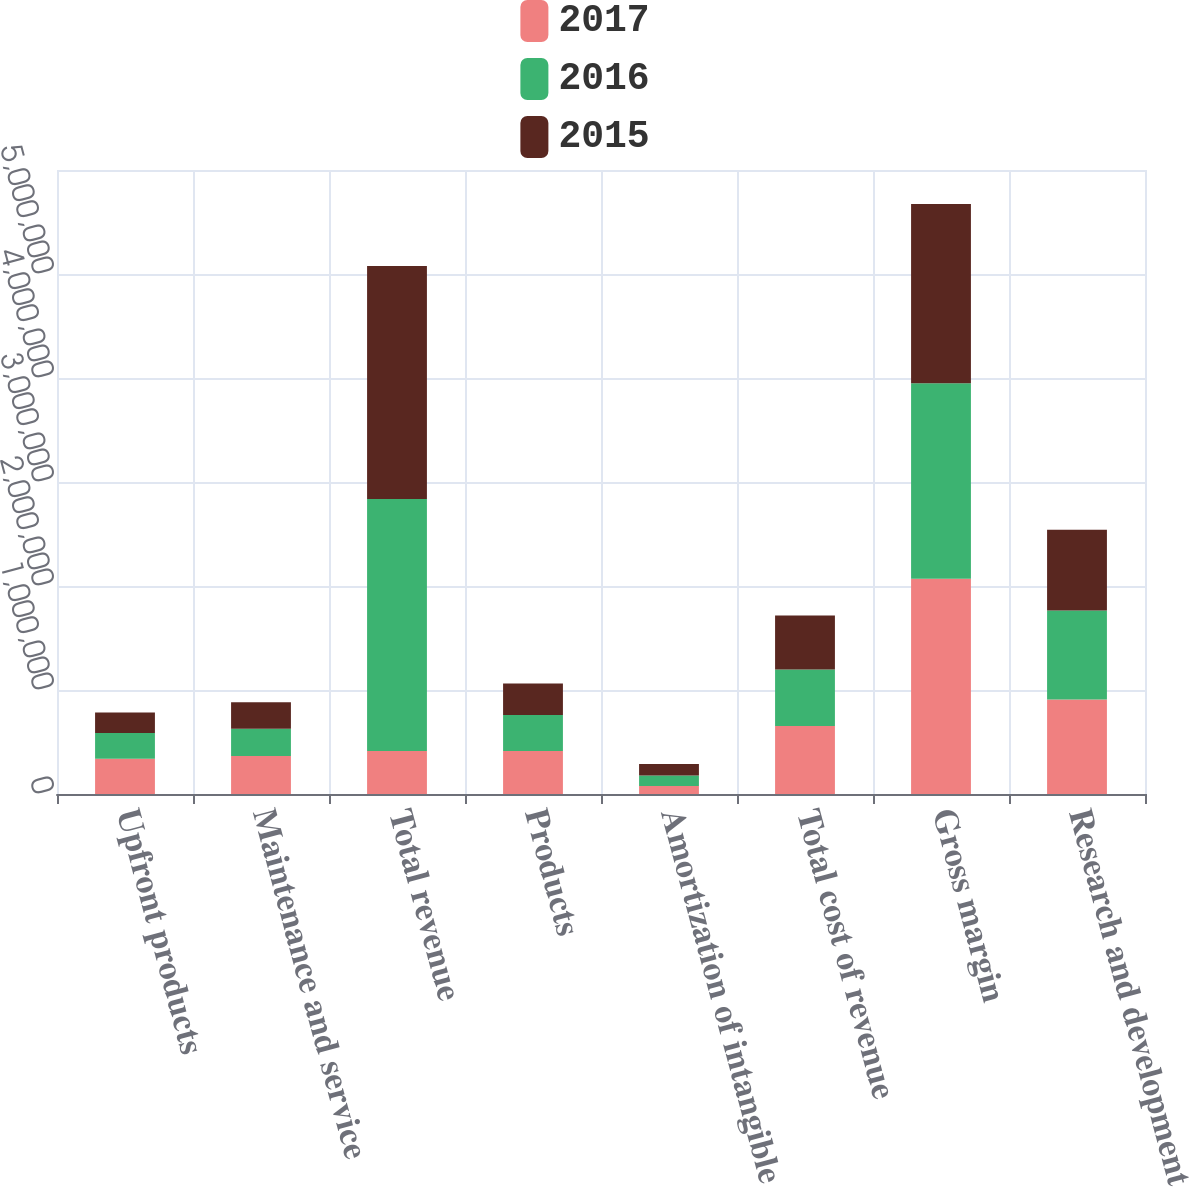Convert chart to OTSL. <chart><loc_0><loc_0><loc_500><loc_500><stacked_bar_chart><ecel><fcel>Upfront products<fcel>Maintenance and service<fcel>Total revenue<fcel>Products<fcel>Amortization of intangible<fcel>Total cost of revenue<fcel>Gross margin<fcel>Research and development<nl><fcel>2017<fcel>338204<fcel>364864<fcel>413203<fcel>413203<fcel>76109<fcel>654184<fcel>2.0707e+06<fcel>908841<nl><fcel>2016<fcel>248137<fcel>263493<fcel>2.42253e+06<fcel>346825<fcel>102118<fcel>542962<fcel>1.87957e+06<fcel>856705<nl><fcel>2015<fcel>197325<fcel>252674<fcel>2.24221e+06<fcel>303633<fcel>110045<fcel>518920<fcel>1.72329e+06<fcel>776229<nl></chart> 